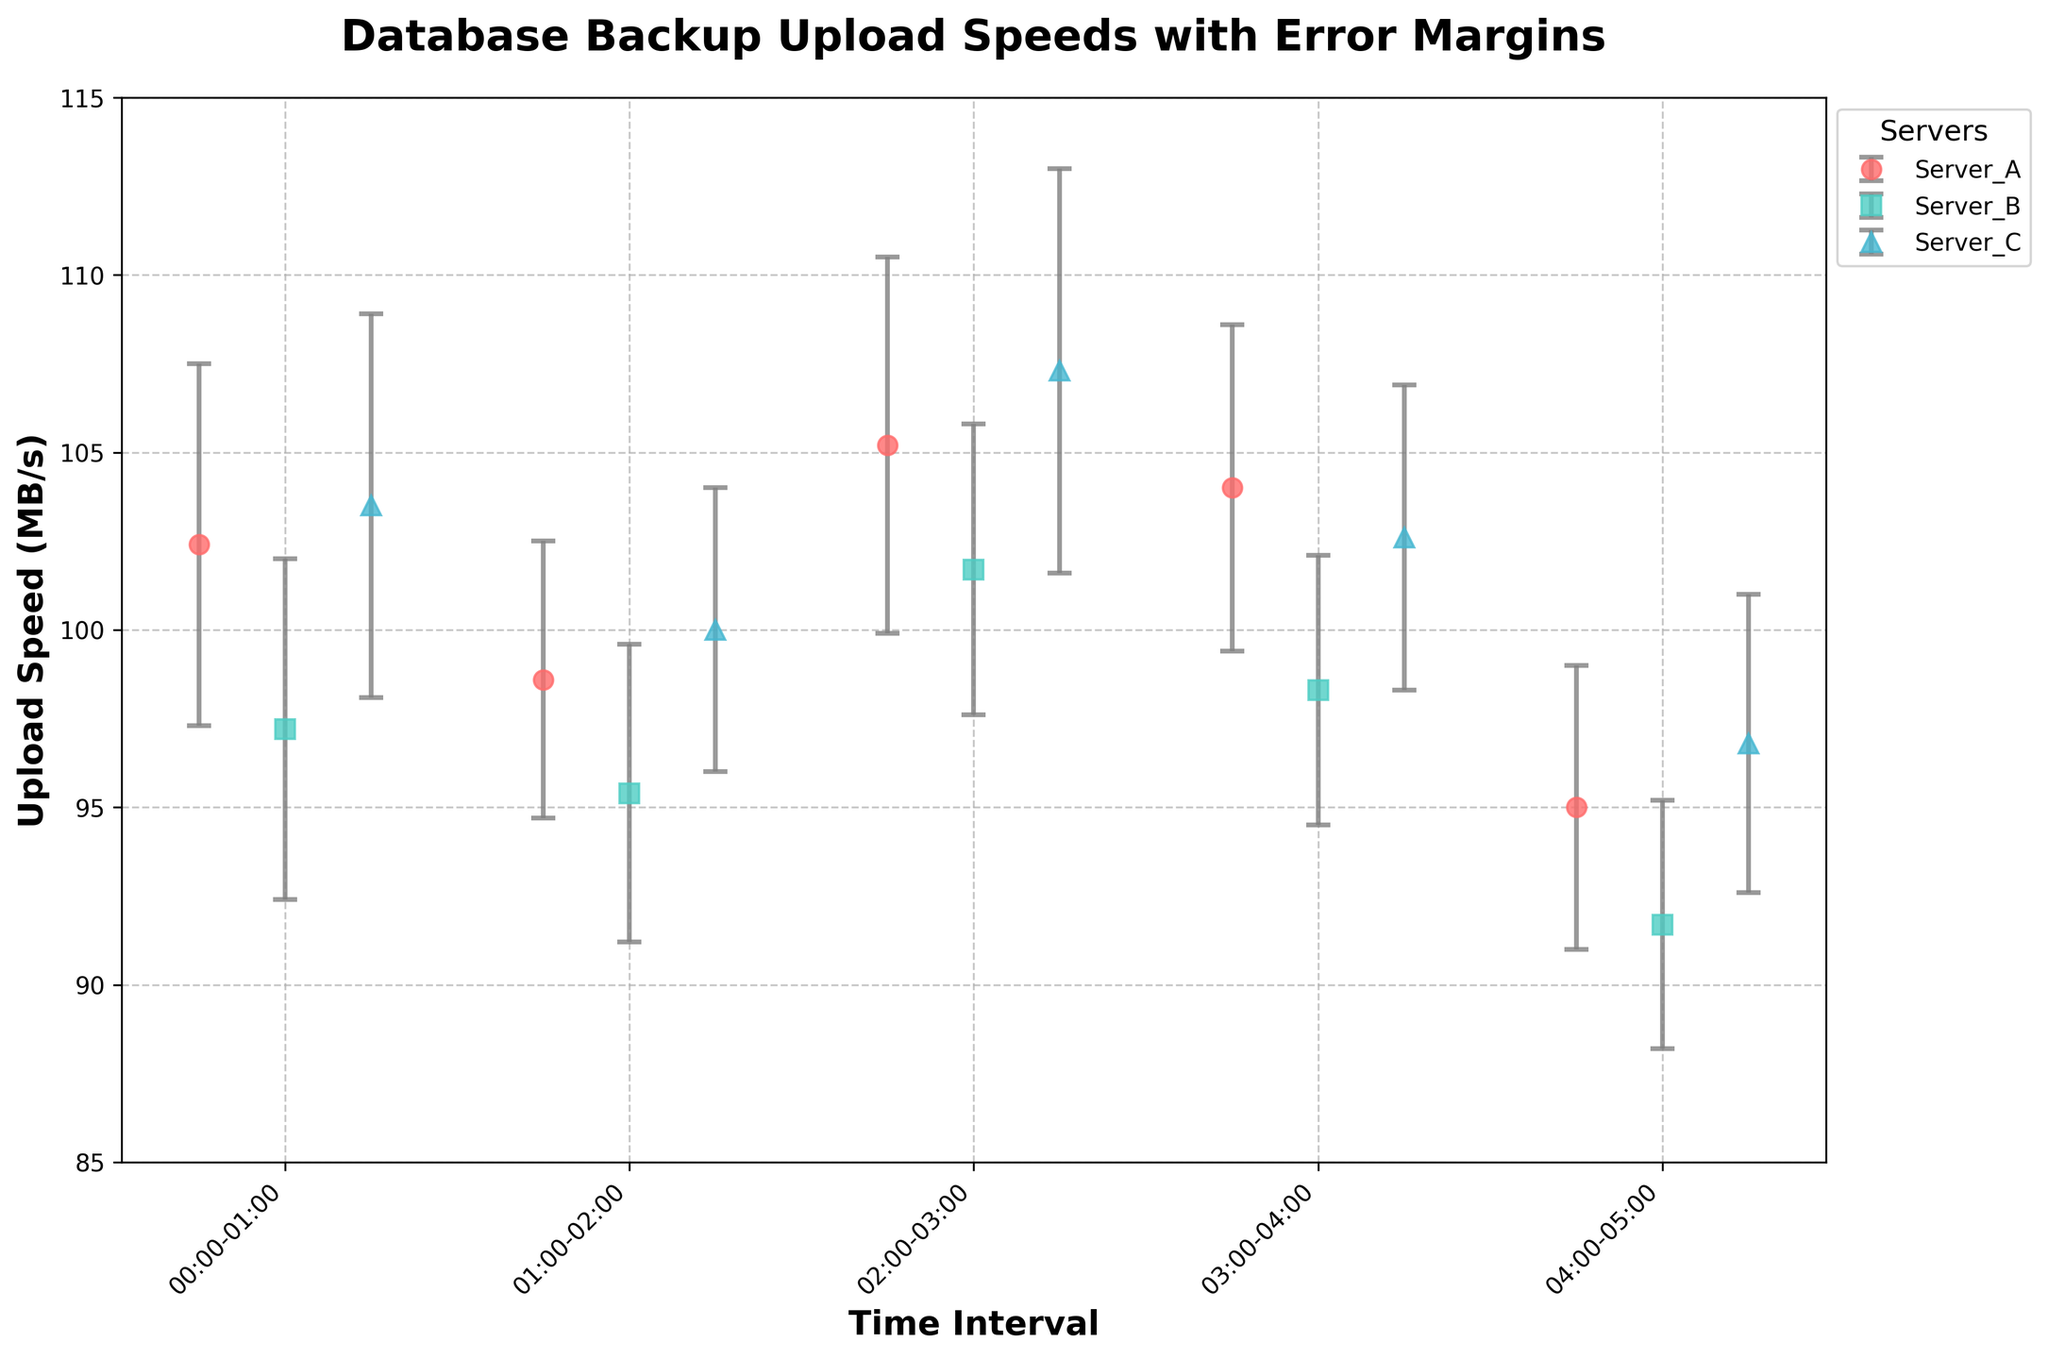what is the title of the plot? Look at the top center of the plot to find the title.
Answer: Database Backup Upload Speeds with Error Margins What time interval shows the lowest upload speed for Server_A? Check the y-axis values across different time intervals for Server_A and find the lowest point.
Answer: 04:00-05:00 How many servers are represented in the plot? Identify the number of unique labels in the legend.
Answer: 3 Which server has the highest upload speed across all time intervals? Compare the highest points of error bars across all servers.
Answer: Server_C During the 02:00-03:00 interval, how much higher is Server_C’s upload speed compared to Server_B’s upload speed? Subtract Server_B’s upload speed from Server_C’s upload speed for the given interval.
Answer: 5.6 MB/s Which time interval shows the smallest error margin for any server and what is the value? Compare the height of the error bars across all intervals and servers to find the smallest one.
Answer: 03:00-04:00, 3.5 MB/s for Server_B What’s the average upload speed of Server_B from 00:00-05:00? Sum the upload speeds of Server_B for all time intervals and divide by the number of intervals.
Answer: (97.2 + 95.4 + 101.7 + 98.3 + 91.7) / 5 = 96.86 MB/s Between 00:00 and 01:00, which server has the highest error margin and what is that value? Compare the error margins for each server in the 00:00-01:00 interval.
Answer: Server_C, 5.4 MB/s How does the upload speed trend of Server_A change over the time intervals? Observe the y-axis values for Server_A across all time intervals to determine if they are increasing, decreasing, or fluctuating.
Answer: Fluctuating If the error margins are considered, which server exhibited the least variability across all time intervals? Compare the sum of error margins for each server over all intervals.
Answer: Server_B 